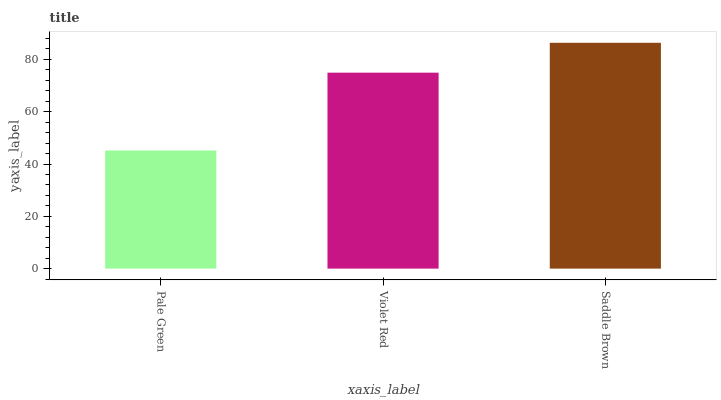Is Pale Green the minimum?
Answer yes or no. Yes. Is Saddle Brown the maximum?
Answer yes or no. Yes. Is Violet Red the minimum?
Answer yes or no. No. Is Violet Red the maximum?
Answer yes or no. No. Is Violet Red greater than Pale Green?
Answer yes or no. Yes. Is Pale Green less than Violet Red?
Answer yes or no. Yes. Is Pale Green greater than Violet Red?
Answer yes or no. No. Is Violet Red less than Pale Green?
Answer yes or no. No. Is Violet Red the high median?
Answer yes or no. Yes. Is Violet Red the low median?
Answer yes or no. Yes. Is Saddle Brown the high median?
Answer yes or no. No. Is Pale Green the low median?
Answer yes or no. No. 